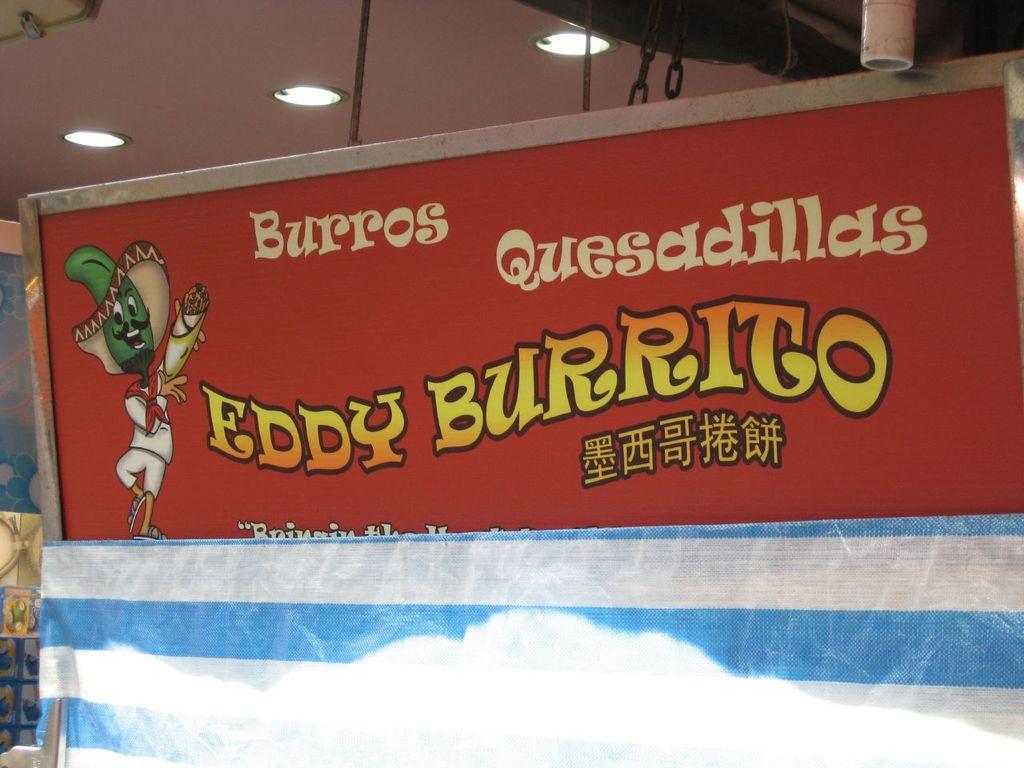Who makes the burritos?
Offer a terse response. Eddy burrito. What type of food is available here?
Provide a short and direct response. Burros quesadillas. 